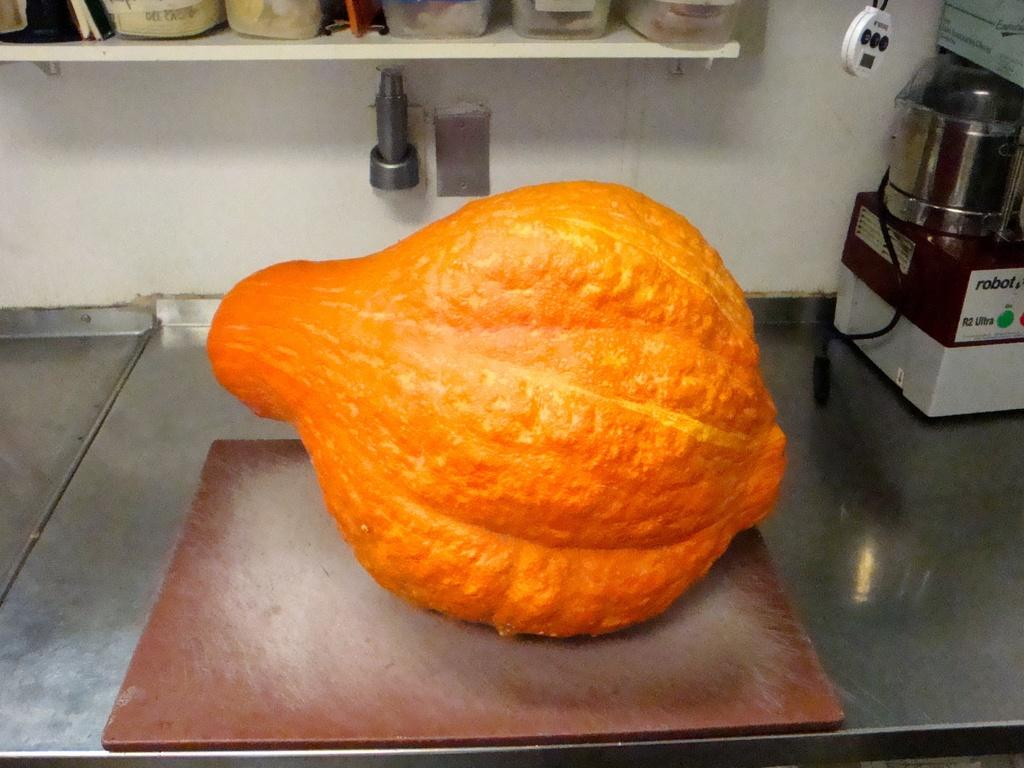Provide a one-sentence caption for the provided image. A large orange squash type plant on a counter next to a Robot R2 Ultra device. 